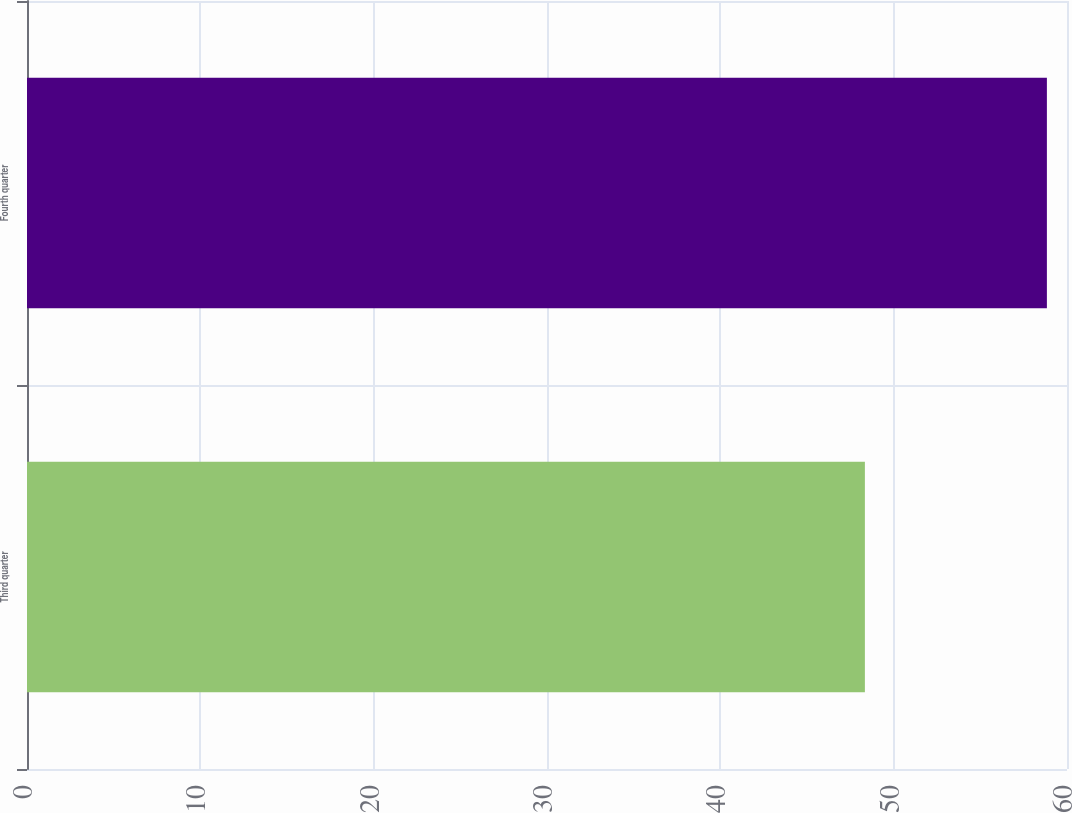Convert chart. <chart><loc_0><loc_0><loc_500><loc_500><bar_chart><fcel>Third quarter<fcel>Fourth quarter<nl><fcel>48.34<fcel>58.84<nl></chart> 